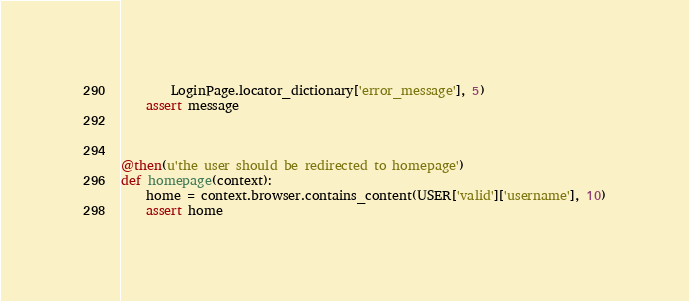Convert code to text. <code><loc_0><loc_0><loc_500><loc_500><_Python_>        LoginPage.locator_dictionary['error_message'], 5)
    assert message



@then(u'the user should be redirected to homepage')
def homepage(context):
    home = context.browser.contains_content(USER['valid']['username'], 10)
    assert home</code> 